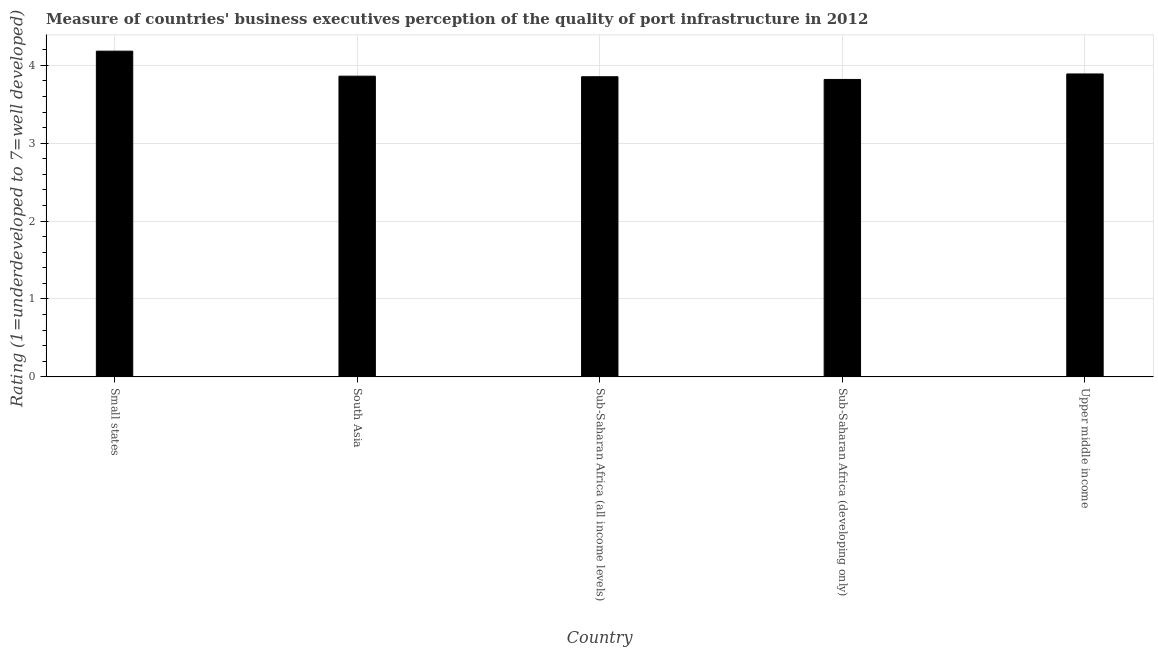What is the title of the graph?
Provide a short and direct response. Measure of countries' business executives perception of the quality of port infrastructure in 2012. What is the label or title of the X-axis?
Provide a succinct answer. Country. What is the label or title of the Y-axis?
Give a very brief answer. Rating (1=underdeveloped to 7=well developed) . What is the rating measuring quality of port infrastructure in Small states?
Provide a succinct answer. 4.18. Across all countries, what is the maximum rating measuring quality of port infrastructure?
Give a very brief answer. 4.18. Across all countries, what is the minimum rating measuring quality of port infrastructure?
Your answer should be compact. 3.82. In which country was the rating measuring quality of port infrastructure maximum?
Provide a short and direct response. Small states. In which country was the rating measuring quality of port infrastructure minimum?
Make the answer very short. Sub-Saharan Africa (developing only). What is the sum of the rating measuring quality of port infrastructure?
Offer a terse response. 19.6. What is the difference between the rating measuring quality of port infrastructure in Small states and Upper middle income?
Provide a short and direct response. 0.29. What is the average rating measuring quality of port infrastructure per country?
Provide a short and direct response. 3.92. What is the median rating measuring quality of port infrastructure?
Give a very brief answer. 3.86. What is the ratio of the rating measuring quality of port infrastructure in Small states to that in Upper middle income?
Your answer should be compact. 1.07. Is the rating measuring quality of port infrastructure in Sub-Saharan Africa (all income levels) less than that in Sub-Saharan Africa (developing only)?
Keep it short and to the point. No. Is the difference between the rating measuring quality of port infrastructure in Sub-Saharan Africa (developing only) and Upper middle income greater than the difference between any two countries?
Offer a terse response. No. What is the difference between the highest and the second highest rating measuring quality of port infrastructure?
Your answer should be compact. 0.29. What is the difference between the highest and the lowest rating measuring quality of port infrastructure?
Provide a succinct answer. 0.36. How many bars are there?
Keep it short and to the point. 5. Are all the bars in the graph horizontal?
Provide a succinct answer. No. How many countries are there in the graph?
Make the answer very short. 5. What is the difference between two consecutive major ticks on the Y-axis?
Provide a succinct answer. 1. What is the Rating (1=underdeveloped to 7=well developed)  of Small states?
Provide a short and direct response. 4.18. What is the Rating (1=underdeveloped to 7=well developed)  in South Asia?
Your answer should be very brief. 3.86. What is the Rating (1=underdeveloped to 7=well developed)  in Sub-Saharan Africa (all income levels)?
Make the answer very short. 3.85. What is the Rating (1=underdeveloped to 7=well developed)  in Sub-Saharan Africa (developing only)?
Offer a very short reply. 3.82. What is the Rating (1=underdeveloped to 7=well developed)  of Upper middle income?
Provide a short and direct response. 3.89. What is the difference between the Rating (1=underdeveloped to 7=well developed)  in Small states and South Asia?
Your answer should be compact. 0.32. What is the difference between the Rating (1=underdeveloped to 7=well developed)  in Small states and Sub-Saharan Africa (all income levels)?
Give a very brief answer. 0.33. What is the difference between the Rating (1=underdeveloped to 7=well developed)  in Small states and Sub-Saharan Africa (developing only)?
Ensure brevity in your answer.  0.36. What is the difference between the Rating (1=underdeveloped to 7=well developed)  in Small states and Upper middle income?
Your answer should be compact. 0.29. What is the difference between the Rating (1=underdeveloped to 7=well developed)  in South Asia and Sub-Saharan Africa (all income levels)?
Your answer should be compact. 0.01. What is the difference between the Rating (1=underdeveloped to 7=well developed)  in South Asia and Sub-Saharan Africa (developing only)?
Make the answer very short. 0.04. What is the difference between the Rating (1=underdeveloped to 7=well developed)  in South Asia and Upper middle income?
Your answer should be very brief. -0.03. What is the difference between the Rating (1=underdeveloped to 7=well developed)  in Sub-Saharan Africa (all income levels) and Sub-Saharan Africa (developing only)?
Your answer should be compact. 0.03. What is the difference between the Rating (1=underdeveloped to 7=well developed)  in Sub-Saharan Africa (all income levels) and Upper middle income?
Ensure brevity in your answer.  -0.04. What is the difference between the Rating (1=underdeveloped to 7=well developed)  in Sub-Saharan Africa (developing only) and Upper middle income?
Offer a terse response. -0.07. What is the ratio of the Rating (1=underdeveloped to 7=well developed)  in Small states to that in South Asia?
Your answer should be very brief. 1.08. What is the ratio of the Rating (1=underdeveloped to 7=well developed)  in Small states to that in Sub-Saharan Africa (all income levels)?
Make the answer very short. 1.08. What is the ratio of the Rating (1=underdeveloped to 7=well developed)  in Small states to that in Sub-Saharan Africa (developing only)?
Provide a short and direct response. 1.09. What is the ratio of the Rating (1=underdeveloped to 7=well developed)  in Small states to that in Upper middle income?
Your response must be concise. 1.07. What is the ratio of the Rating (1=underdeveloped to 7=well developed)  in South Asia to that in Sub-Saharan Africa (all income levels)?
Your response must be concise. 1. What is the ratio of the Rating (1=underdeveloped to 7=well developed)  in South Asia to that in Upper middle income?
Provide a succinct answer. 0.99. What is the ratio of the Rating (1=underdeveloped to 7=well developed)  in Sub-Saharan Africa (all income levels) to that in Sub-Saharan Africa (developing only)?
Your answer should be compact. 1.01. What is the ratio of the Rating (1=underdeveloped to 7=well developed)  in Sub-Saharan Africa (all income levels) to that in Upper middle income?
Your answer should be compact. 0.99. What is the ratio of the Rating (1=underdeveloped to 7=well developed)  in Sub-Saharan Africa (developing only) to that in Upper middle income?
Provide a short and direct response. 0.98. 